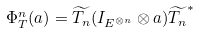Convert formula to latex. <formula><loc_0><loc_0><loc_500><loc_500>\Phi _ { T } ^ { n } ( a ) = \widetilde { T _ { n } } ( I _ { E ^ { \otimes n } } \otimes a ) \widetilde { T _ { n } } ^ { * }</formula> 